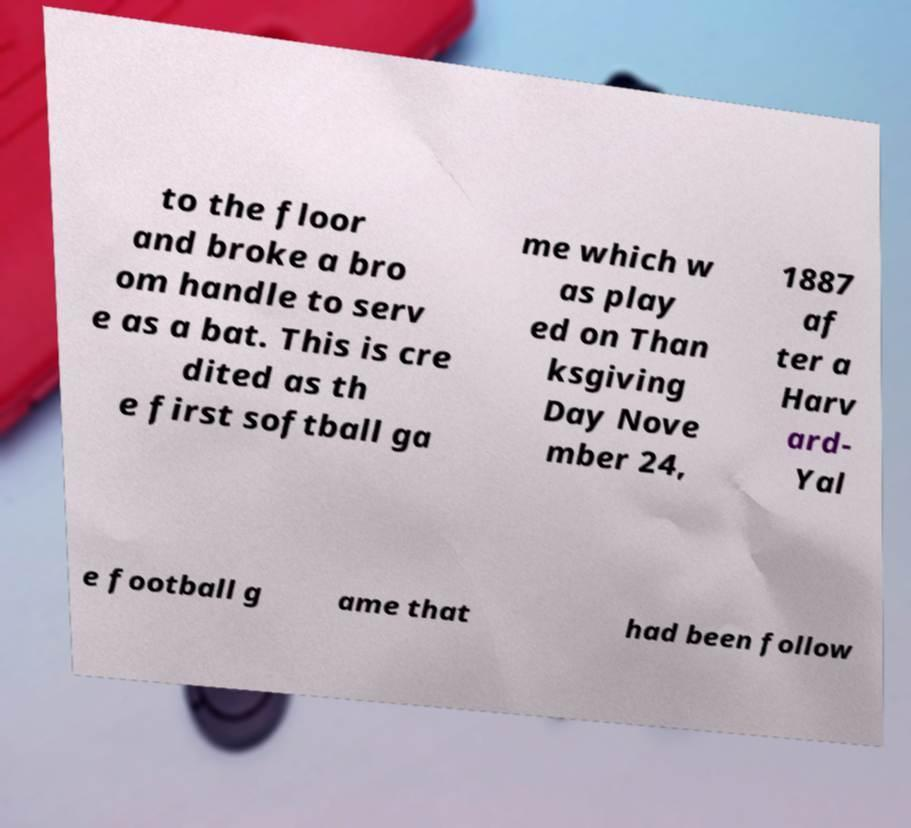Could you assist in decoding the text presented in this image and type it out clearly? to the floor and broke a bro om handle to serv e as a bat. This is cre dited as th e first softball ga me which w as play ed on Than ksgiving Day Nove mber 24, 1887 af ter a Harv ard- Yal e football g ame that had been follow 